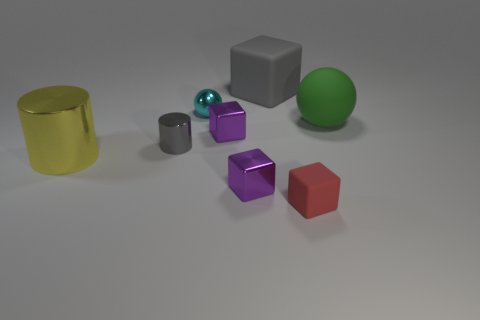The large object that is to the left of the green ball and to the right of the tiny gray metallic object has what shape?
Make the answer very short. Cube. What size is the rubber object that is the same shape as the small cyan metal object?
Your answer should be compact. Large. How many purple things are made of the same material as the gray cube?
Your answer should be compact. 0. Is the color of the matte ball the same as the cylinder to the right of the large yellow object?
Provide a short and direct response. No. Are there more blocks than tiny cyan objects?
Provide a short and direct response. Yes. What color is the big matte sphere?
Provide a succinct answer. Green. Do the large rubber thing in front of the small cyan object and the tiny matte cube have the same color?
Make the answer very short. No. There is a cylinder that is the same color as the big rubber cube; what material is it?
Give a very brief answer. Metal. What number of rubber cubes are the same color as the small metallic cylinder?
Ensure brevity in your answer.  1. There is a big rubber thing on the left side of the red object; does it have the same shape as the red rubber thing?
Your response must be concise. Yes. 